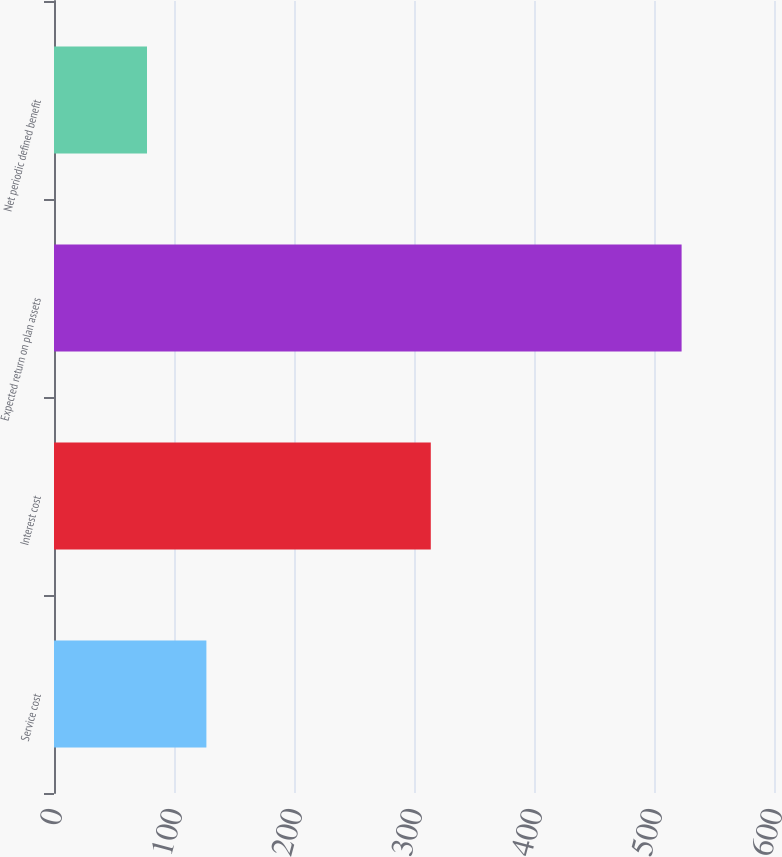Convert chart to OTSL. <chart><loc_0><loc_0><loc_500><loc_500><bar_chart><fcel>Service cost<fcel>Interest cost<fcel>Expected return on plan assets<fcel>Net periodic defined benefit<nl><fcel>127<fcel>314<fcel>523<fcel>77.5<nl></chart> 